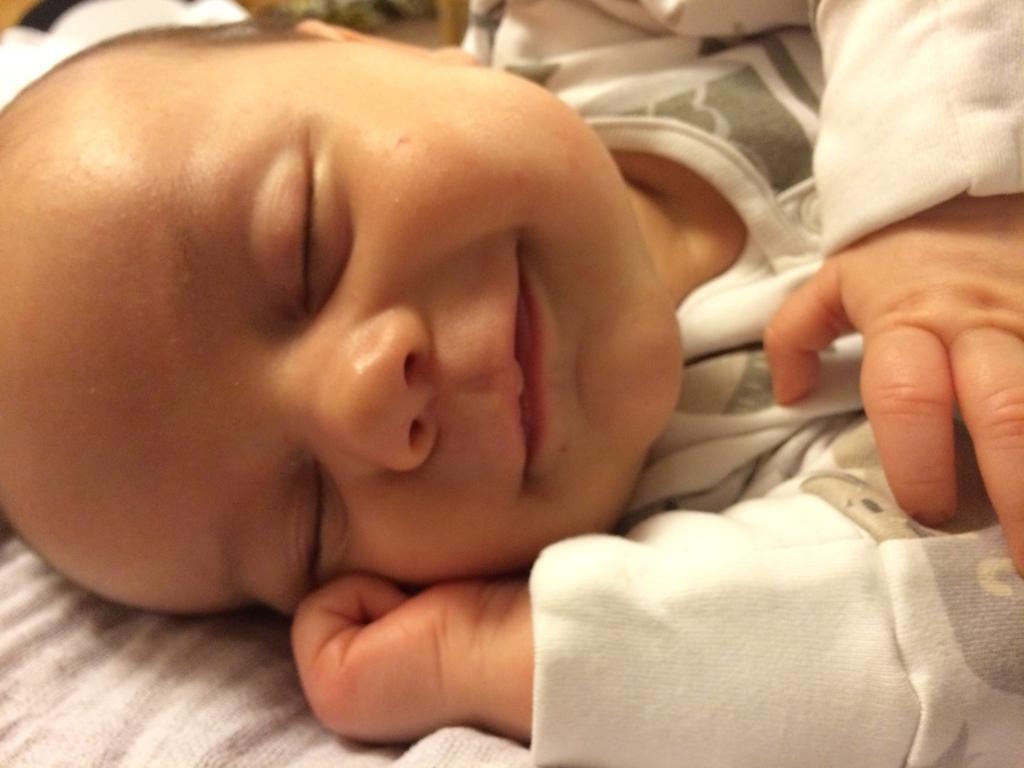In one or two sentences, can you explain what this image depicts? In this image we can see a kid sleeping. At the bottom there is a cloth. 